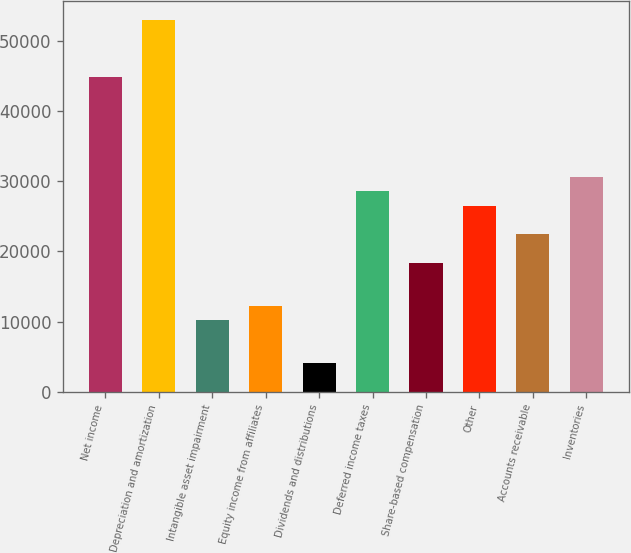<chart> <loc_0><loc_0><loc_500><loc_500><bar_chart><fcel>Net income<fcel>Depreciation and amortization<fcel>Intangible asset impairment<fcel>Equity income from affiliates<fcel>Dividends and distributions<fcel>Deferred income taxes<fcel>Share-based compensation<fcel>Other<fcel>Accounts receivable<fcel>Inventories<nl><fcel>44899<fcel>53061<fcel>10210.5<fcel>12251<fcel>4089<fcel>28575<fcel>18372.5<fcel>26534.5<fcel>22453.5<fcel>30615.5<nl></chart> 